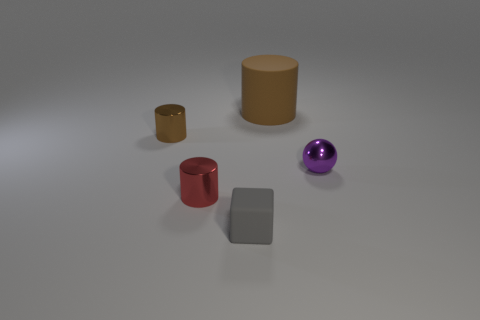Subtract all brown cylinders. How many were subtracted if there are1brown cylinders left? 1 Add 4 balls. How many objects exist? 9 Subtract all cubes. How many objects are left? 4 Add 1 purple shiny things. How many purple shiny things are left? 2 Add 2 tiny red shiny things. How many tiny red shiny things exist? 3 Subtract 0 blue blocks. How many objects are left? 5 Subtract all big matte cylinders. Subtract all purple metal balls. How many objects are left? 3 